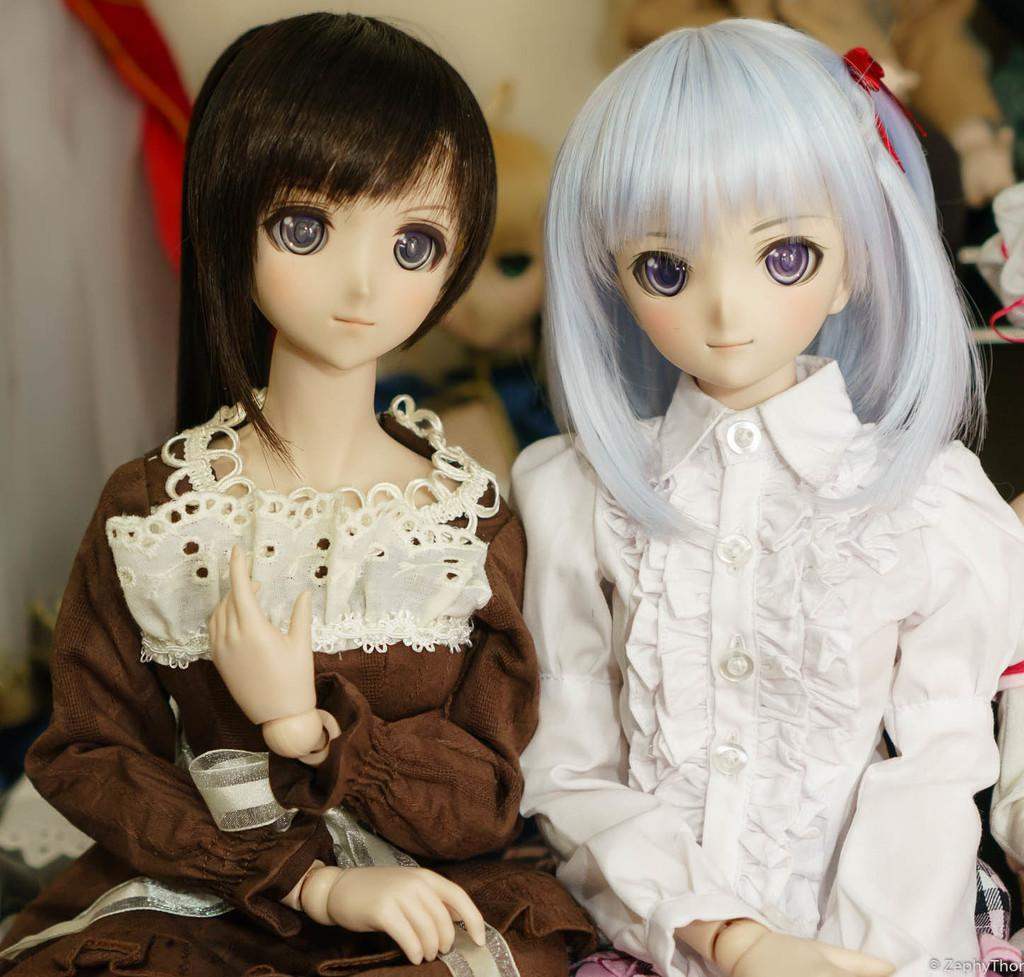How many dolls are present in the image? There are two dolls in the image. What colors are the dresses of the dolls? One doll is wearing a white dress, and the other doll is wearing a brown dress. Can you describe the background of the image? The background of the image is blurry. Are there any other dolls visible in the image? Yes, there are other dolls visible in the background. What type of cheese is being used to represent the dolls in the image? There is no cheese present in the image, and the dolls are not represented by any cheese. 